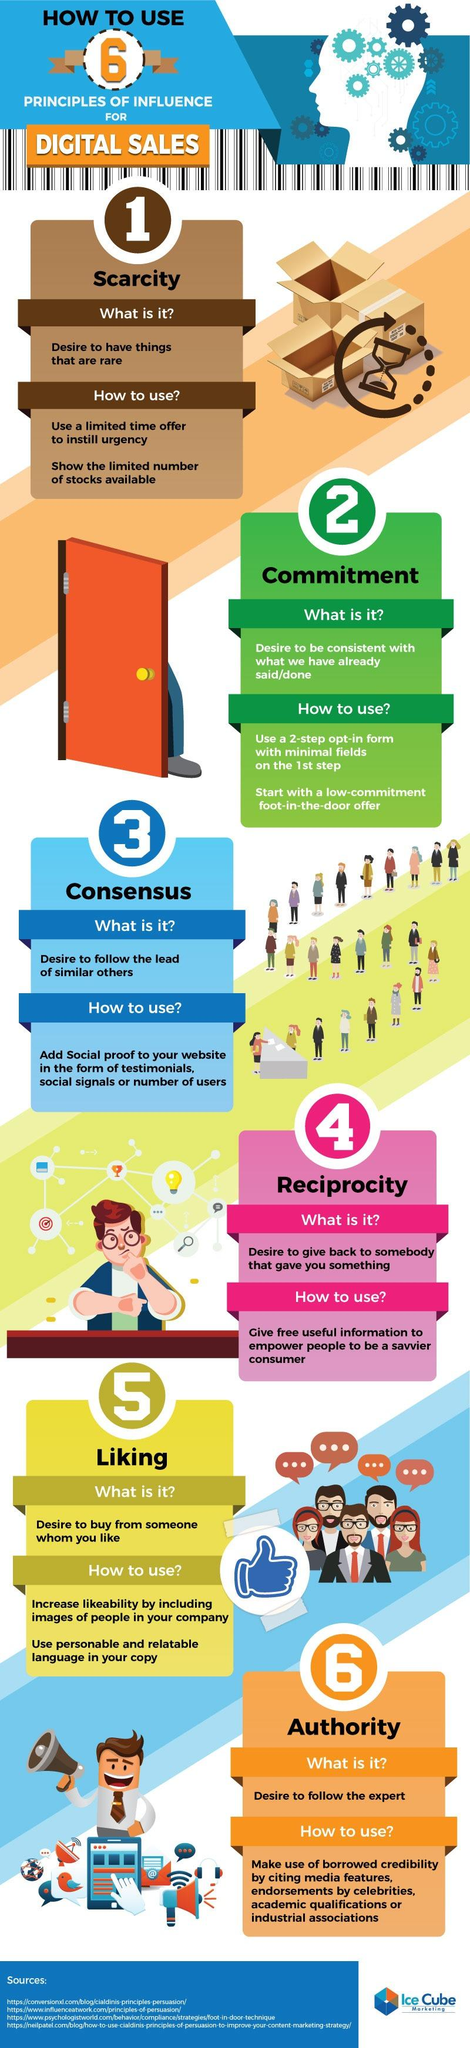Outline some significant characteristics in this image. Showing a limited number of stocks is a way to support the principle of scarcity. 